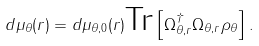<formula> <loc_0><loc_0><loc_500><loc_500>d \mu _ { \theta } ( r ) = d \mu _ { \theta , 0 } ( r ) \text {Tr} \left [ \Omega _ { \theta , r } ^ { \dagger } \Omega _ { \theta , r } \rho _ { \theta } \right ] .</formula> 